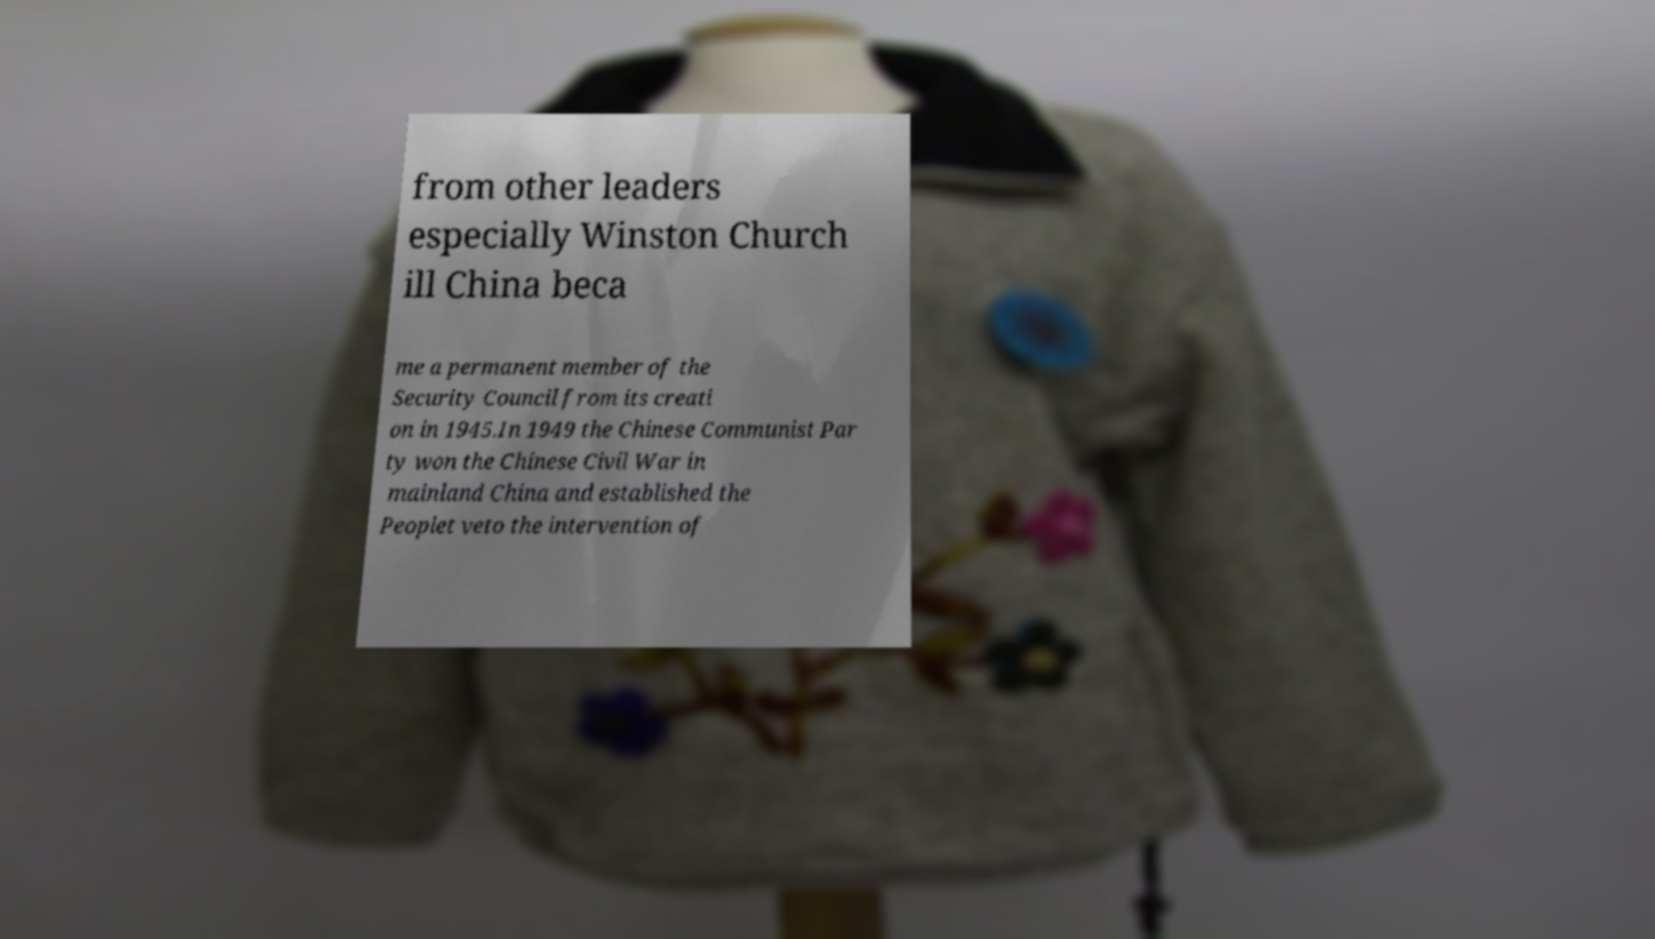What messages or text are displayed in this image? I need them in a readable, typed format. from other leaders especially Winston Church ill China beca me a permanent member of the Security Council from its creati on in 1945.In 1949 the Chinese Communist Par ty won the Chinese Civil War in mainland China and established the Peoplet veto the intervention of 